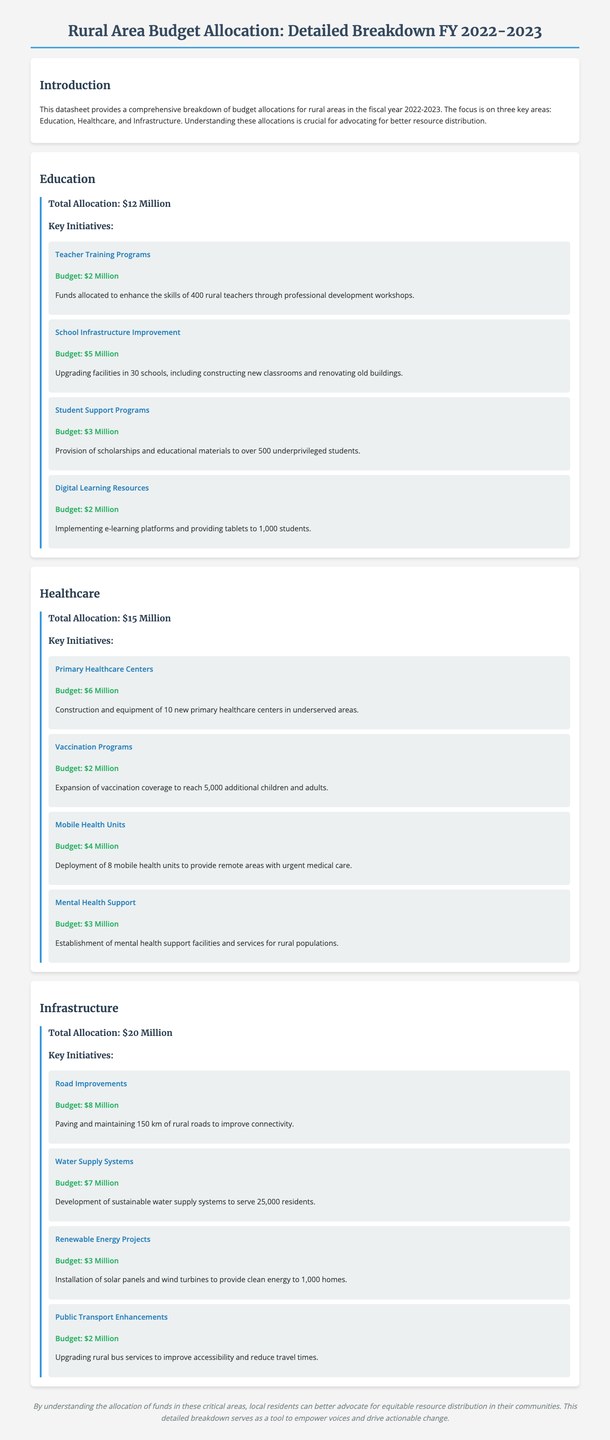What is the total allocation for education? The total allocation for education is detailed in the education section of the document, which states $12 Million.
Answer: $12 Million How much was allocated for healthcare? The healthcare section specifies the total allocation as $15 Million.
Answer: $15 Million What is the budget for primary healthcare centers? The healthcare section mentions that the budget for primary healthcare centers is $6 Million.
Answer: $6 Million How many schools will benefit from infrastructure improvement? The document states that infrastructure improvement will enhance facilities in 30 schools.
Answer: 30 schools What is the budget for mobile health units? The healthcare section provides the budget for mobile health units as $4 Million.
Answer: $4 Million How many kilometers of roads will be improved? The infrastructure section indicates that improvements will be made to 150 km of rural roads.
Answer: 150 km What is the total infrastructure allocation? The total allocation for infrastructure is given in the infrastructure section as $20 Million.
Answer: $20 Million How many students will receive scholarships? The education section notes that over 500 underprivileged students will be supported with scholarships.
Answer: 500 students What initiative has a budget of $3 Million related to renewable energy? The infrastructure section describes the renewable energy projects, which have a budget of $3 Million.
Answer: Renewable Energy Projects How much funding is designated for mental health support? The healthcare section identifies the budget for mental health support facilities as $3 Million.
Answer: $3 Million 